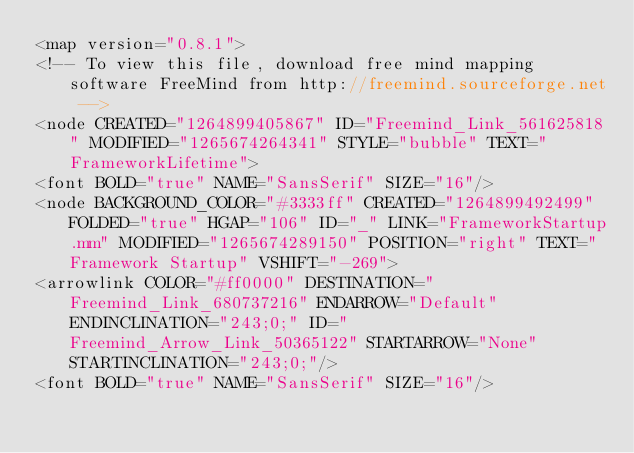Convert code to text. <code><loc_0><loc_0><loc_500><loc_500><_ObjectiveC_><map version="0.8.1">
<!-- To view this file, download free mind mapping software FreeMind from http://freemind.sourceforge.net -->
<node CREATED="1264899405867" ID="Freemind_Link_561625818" MODIFIED="1265674264341" STYLE="bubble" TEXT="FrameworkLifetime">
<font BOLD="true" NAME="SansSerif" SIZE="16"/>
<node BACKGROUND_COLOR="#3333ff" CREATED="1264899492499" FOLDED="true" HGAP="106" ID="_" LINK="FrameworkStartup.mm" MODIFIED="1265674289150" POSITION="right" TEXT="Framework Startup" VSHIFT="-269">
<arrowlink COLOR="#ff0000" DESTINATION="Freemind_Link_680737216" ENDARROW="Default" ENDINCLINATION="243;0;" ID="Freemind_Arrow_Link_50365122" STARTARROW="None" STARTINCLINATION="243;0;"/>
<font BOLD="true" NAME="SansSerif" SIZE="16"/></code> 